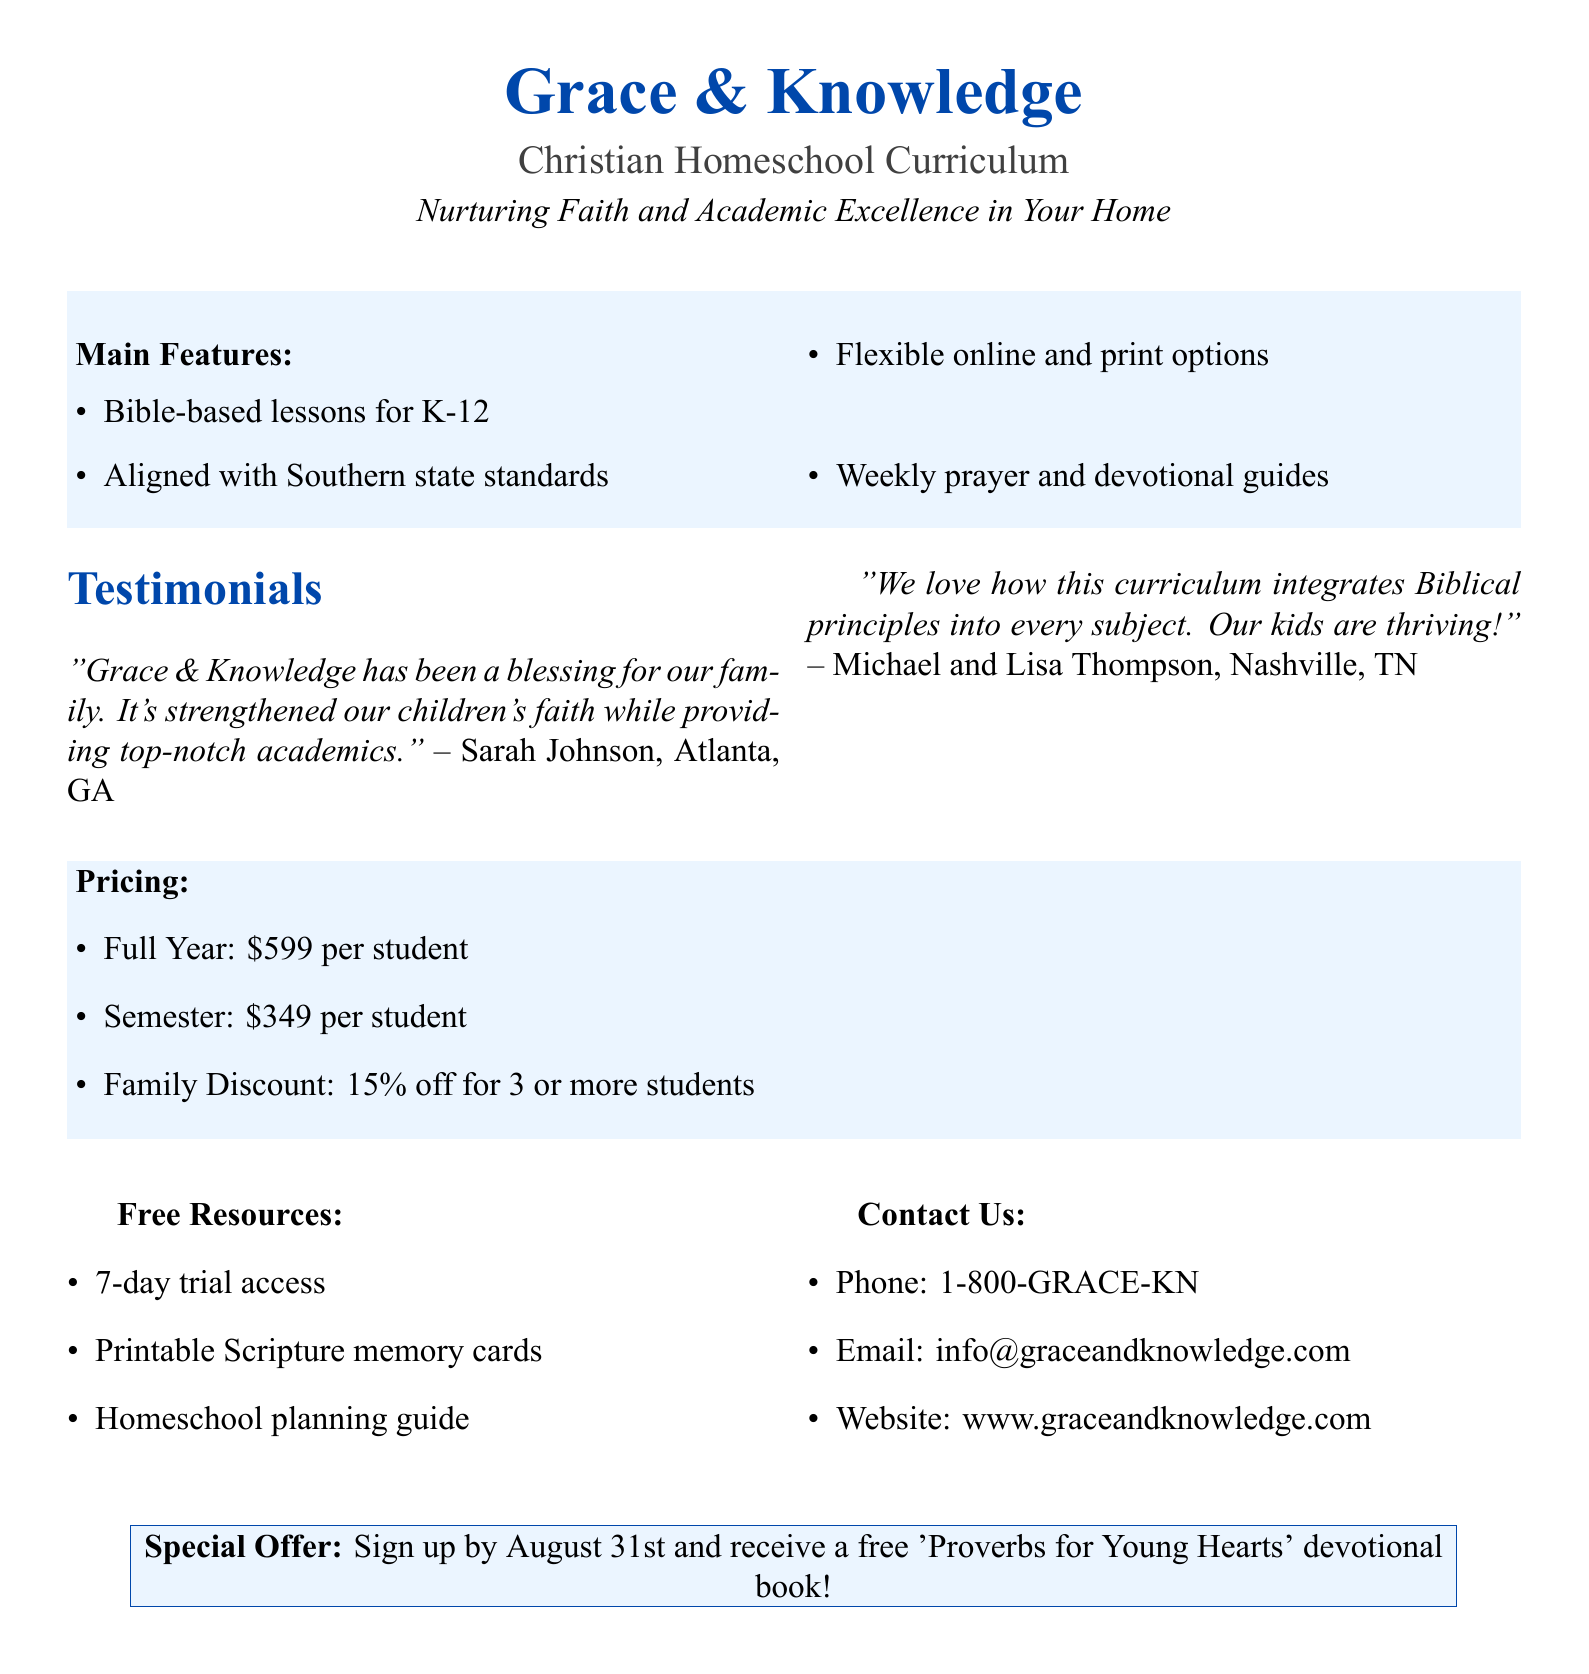What is the header of the document? The header introduces the curriculum and is prominently displayed at the top of the document.
Answer: Grace & Knowledge Christian Homeschool Curriculum What is the tagline? The tagline summarizes the mission of the curriculum, emphasizing both faith and academics.
Answer: Nurturing Faith and Academic Excellence in Your Home What discounts are available for families? Discounts for families are typically highlighted to encourage larger enrollments and are expressed as a percentage.
Answer: 15% off for 3 or more students Who gave a testimonial from Atlanta, GA? Testimonials provide personal experiences and endorsements from current users, building credibility.
Answer: Sarah Johnson What is the special offer mentioned in the document? Special offers often create urgency and entice potential customers to enroll.
Answer: Sign up by August 31st and receive a free 'Proverbs for Young Hearts' devotional book! Which features align with Southern state standards? This question assesses the relevance of the curriculum to regional requirements for education.
Answer: Aligned with Southern state standards How much does a full year of the curriculum cost? Pricing information is a key aspect of promotional material and helps families budget for the curriculum.
Answer: $599 per student What type of resources are provided for free with the curriculum? Free resources are a value-add that can attract buyers looking for comprehensive support.
Answer: 7-day trial access, Printable Scripture memory cards, Homeschool planning guide What is one of the main features of the curriculum? Identifying key features can help families understand what differentiates this curriculum from others.
Answer: Bible-based lessons for K-12 